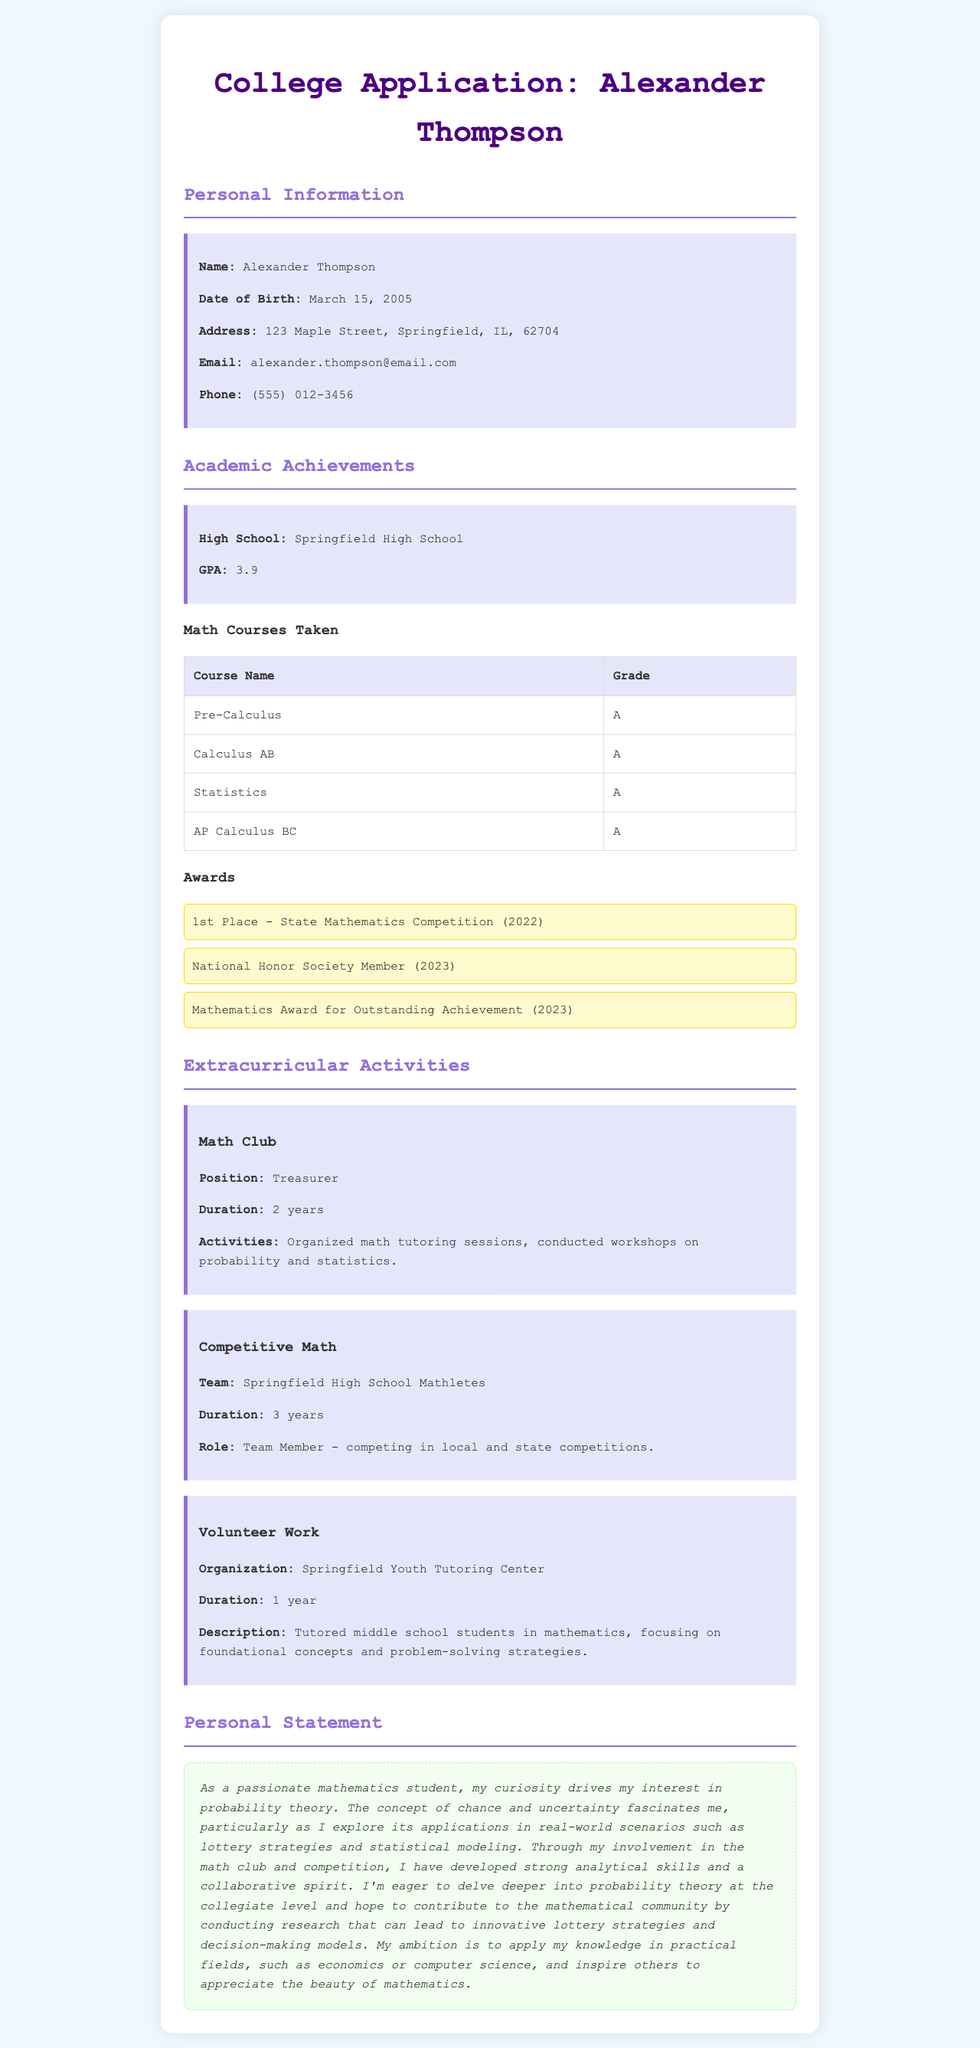What is the applicant's GPA? The GPA listed in the academic achievements section is 3.9.
Answer: 3.9 What award did Alexander Thompson receive in 2022? The award for 1st Place at the State Mathematics Competition is noted for the year 2022.
Answer: 1st Place - State Mathematics Competition How long did Alexander serve as Treasurer of the Math Club? The document states that Alexander served as Treasurer for 2 years in the Math Club.
Answer: 2 years What personal interest is highlighted in the personal statement? The personal statement emphasizes Alexander's interest in probability theory.
Answer: Probability theory In which extracurricular activity did Alexander compete for 3 years? The Competitive Math section indicates that Alexander was involved in the Springfield High School Mathletes for 3 years.
Answer: Springfield High School Mathletes What type of student did Alexander tutor at the Springfield Youth Tutoring Center? The document mentions that Alexander tutored middle school students in mathematics.
Answer: Middle school students What subjects were included in Alexander's math courses? The listed courses included Pre-Calculus, Calculus AB, Statistics, and AP Calculus BC.
Answer: Pre-Calculus, Calculus AB, Statistics, AP Calculus BC How does Alexander plan to apply his knowledge after college? The personal statement suggests he aims to apply his knowledge in practical fields like economics or computer science.
Answer: Economics or computer science 